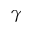<formula> <loc_0><loc_0><loc_500><loc_500>\gamma</formula> 